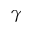<formula> <loc_0><loc_0><loc_500><loc_500>\gamma</formula> 